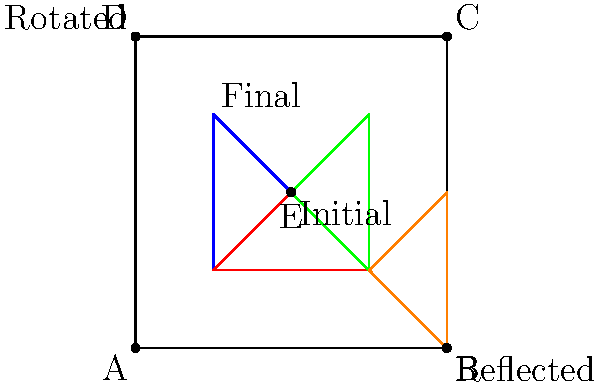In the diagram above, a triangle representing a protagonist's emotional state undergoes a series of transformations, mirroring their complex journey. The triangle starts at point E and experiences the following sequence:

1. Reflection across the diagonal AC
2. 90° clockwise rotation around point E
3. Translation 1 unit left and 1 unit down

If the final position of the triangle represents the protagonist's emotional resolution, what series of transformations would bring them back to their initial state? Express your answer as a composition of transformations in the correct order. To bring the protagonist's emotional state back to its initial position, we need to reverse the sequence of transformations applied. Let's break it down step-by-step:

1. The last transformation was a translation of 1 unit left and 1 unit down. To reverse this, we need to translate 1 unit right and 1 unit up. This can be expressed as $T_{(1,1)}$.

2. Before the translation, there was a 90° clockwise rotation around point E. To reverse this, we need to rotate 90° counterclockwise (or 270° clockwise) around the same point. This can be expressed as $R_{E,270°}$.

3. The first transformation was a reflection across the diagonal AC. Reflections are their own inverses, so we simply need to reflect across AC again. This can be expressed as $ref_{AC}$.

To compose these transformations, we apply them in the reverse order of the original sequence. In transformation notation, we write the rightmost transformation first, as it's applied first to the input.

Therefore, the composition of transformations to return to the initial state is:

$ref_{AC} \circ R_{E,270°} \circ T_{(1,1)}$

This sequence will first translate the triangle back, then rotate it to its previous orientation, and finally reflect it back to its initial position.
Answer: $ref_{AC} \circ R_{E,270°} \circ T_{(1,1)}$ 